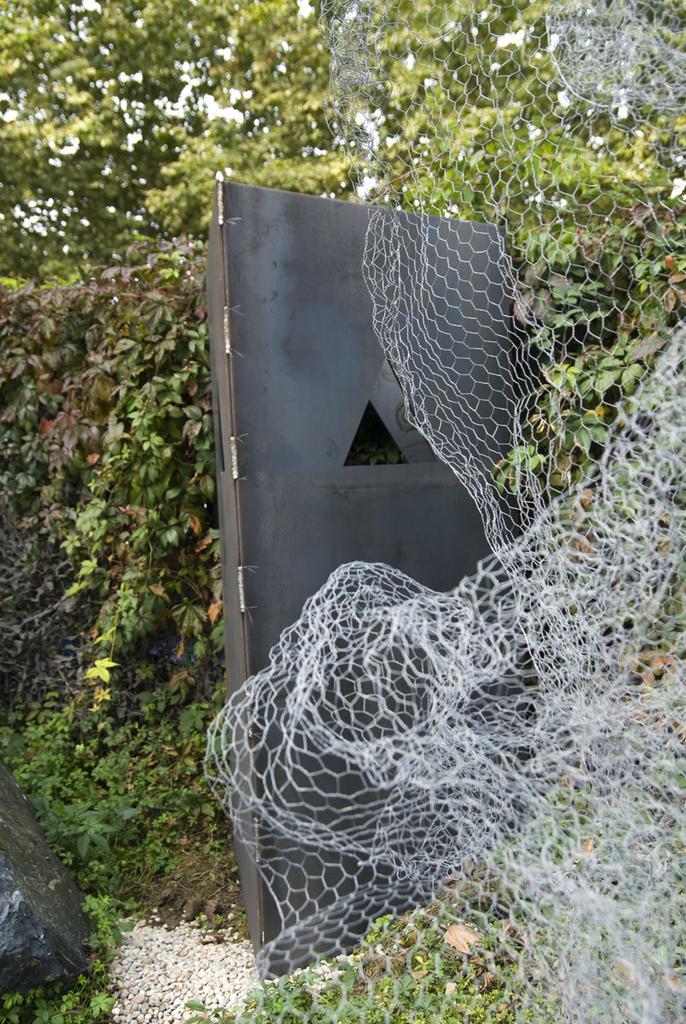How would you summarize this image in a sentence or two? In this image we can see the net, black color door, the rock and the trees in the background. 